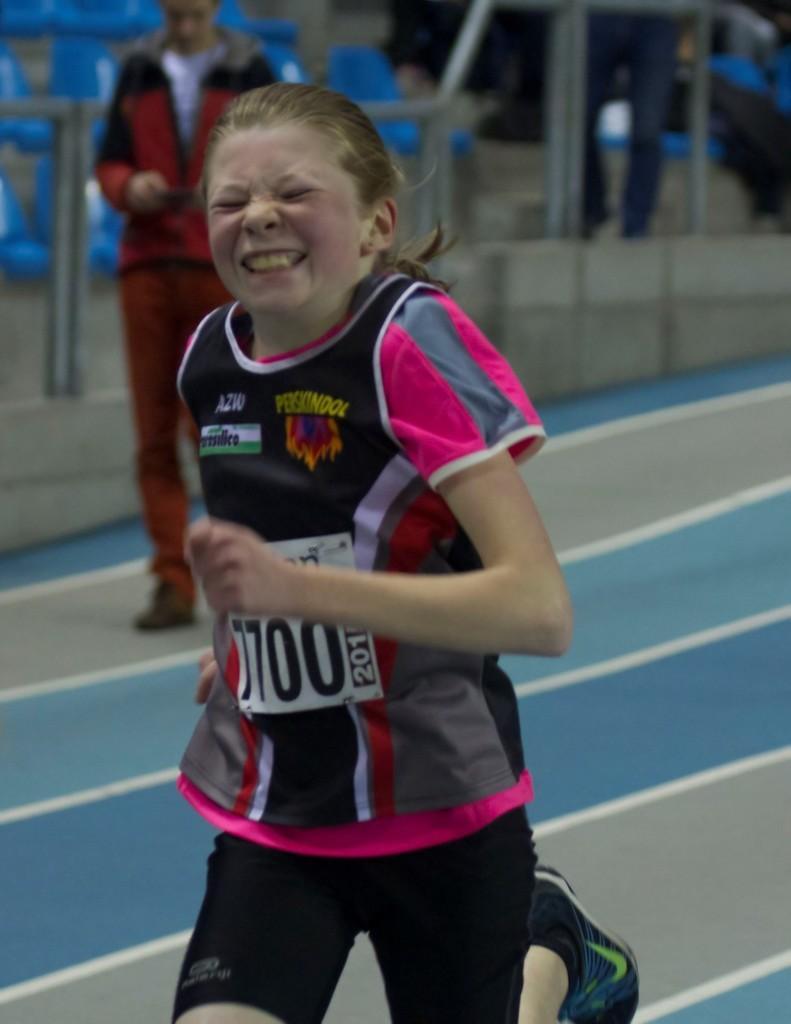Could you give a brief overview of what you see in this image? In this image we can see one girl running in a race, one man standing and holds an object. Backside of the man there are so many chairs, poles and objects. 